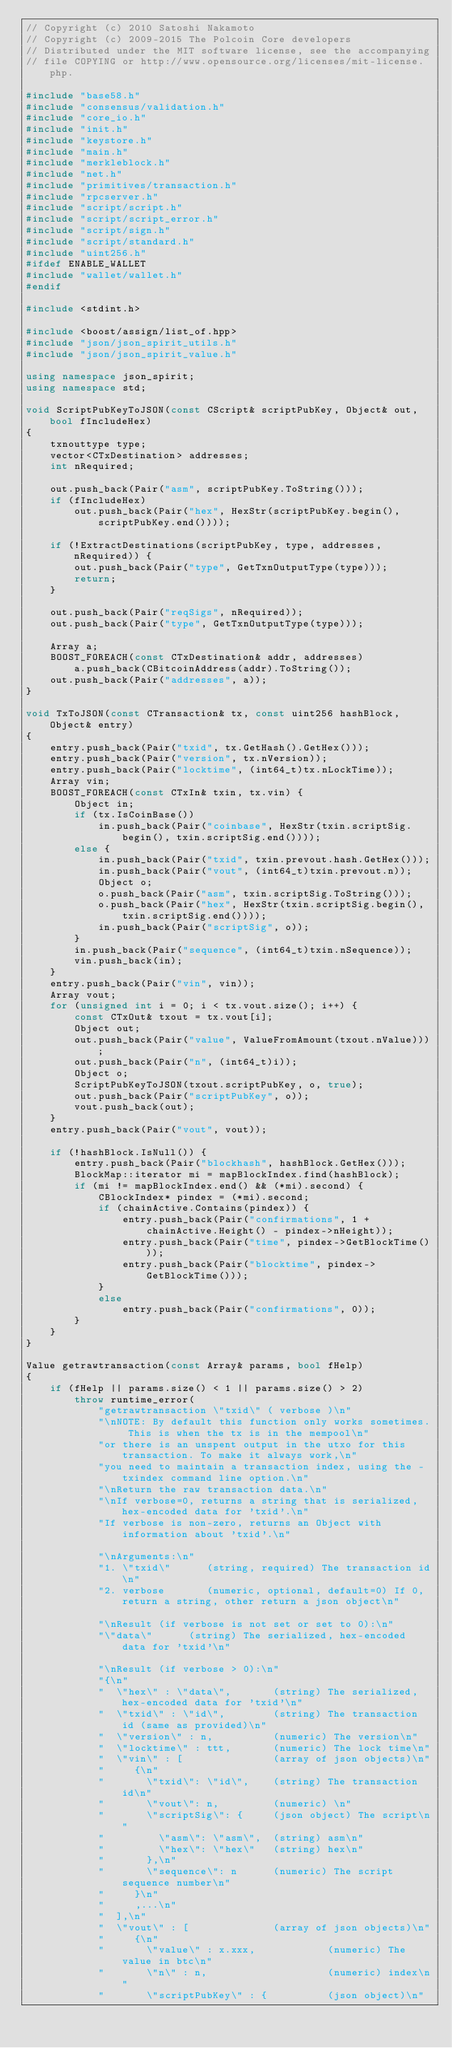Convert code to text. <code><loc_0><loc_0><loc_500><loc_500><_C++_>// Copyright (c) 2010 Satoshi Nakamoto
// Copyright (c) 2009-2015 The Polcoin Core developers
// Distributed under the MIT software license, see the accompanying
// file COPYING or http://www.opensource.org/licenses/mit-license.php.

#include "base58.h"
#include "consensus/validation.h"
#include "core_io.h"
#include "init.h"
#include "keystore.h"
#include "main.h"
#include "merkleblock.h"
#include "net.h"
#include "primitives/transaction.h"
#include "rpcserver.h"
#include "script/script.h"
#include "script/script_error.h"
#include "script/sign.h"
#include "script/standard.h"
#include "uint256.h"
#ifdef ENABLE_WALLET
#include "wallet/wallet.h"
#endif

#include <stdint.h>

#include <boost/assign/list_of.hpp>
#include "json/json_spirit_utils.h"
#include "json/json_spirit_value.h"

using namespace json_spirit;
using namespace std;

void ScriptPubKeyToJSON(const CScript& scriptPubKey, Object& out, bool fIncludeHex)
{
    txnouttype type;
    vector<CTxDestination> addresses;
    int nRequired;

    out.push_back(Pair("asm", scriptPubKey.ToString()));
    if (fIncludeHex)
        out.push_back(Pair("hex", HexStr(scriptPubKey.begin(), scriptPubKey.end())));

    if (!ExtractDestinations(scriptPubKey, type, addresses, nRequired)) {
        out.push_back(Pair("type", GetTxnOutputType(type)));
        return;
    }

    out.push_back(Pair("reqSigs", nRequired));
    out.push_back(Pair("type", GetTxnOutputType(type)));

    Array a;
    BOOST_FOREACH(const CTxDestination& addr, addresses)
        a.push_back(CBitcoinAddress(addr).ToString());
    out.push_back(Pair("addresses", a));
}

void TxToJSON(const CTransaction& tx, const uint256 hashBlock, Object& entry)
{
    entry.push_back(Pair("txid", tx.GetHash().GetHex()));
    entry.push_back(Pair("version", tx.nVersion));
    entry.push_back(Pair("locktime", (int64_t)tx.nLockTime));
    Array vin;
    BOOST_FOREACH(const CTxIn& txin, tx.vin) {
        Object in;
        if (tx.IsCoinBase())
            in.push_back(Pair("coinbase", HexStr(txin.scriptSig.begin(), txin.scriptSig.end())));
        else {
            in.push_back(Pair("txid", txin.prevout.hash.GetHex()));
            in.push_back(Pair("vout", (int64_t)txin.prevout.n));
            Object o;
            o.push_back(Pair("asm", txin.scriptSig.ToString()));
            o.push_back(Pair("hex", HexStr(txin.scriptSig.begin(), txin.scriptSig.end())));
            in.push_back(Pair("scriptSig", o));
        }
        in.push_back(Pair("sequence", (int64_t)txin.nSequence));
        vin.push_back(in);
    }
    entry.push_back(Pair("vin", vin));
    Array vout;
    for (unsigned int i = 0; i < tx.vout.size(); i++) {
        const CTxOut& txout = tx.vout[i];
        Object out;
        out.push_back(Pair("value", ValueFromAmount(txout.nValue)));
        out.push_back(Pair("n", (int64_t)i));
        Object o;
        ScriptPubKeyToJSON(txout.scriptPubKey, o, true);
        out.push_back(Pair("scriptPubKey", o));
        vout.push_back(out);
    }
    entry.push_back(Pair("vout", vout));

    if (!hashBlock.IsNull()) {
        entry.push_back(Pair("blockhash", hashBlock.GetHex()));
        BlockMap::iterator mi = mapBlockIndex.find(hashBlock);
        if (mi != mapBlockIndex.end() && (*mi).second) {
            CBlockIndex* pindex = (*mi).second;
            if (chainActive.Contains(pindex)) {
                entry.push_back(Pair("confirmations", 1 + chainActive.Height() - pindex->nHeight));
                entry.push_back(Pair("time", pindex->GetBlockTime()));
                entry.push_back(Pair("blocktime", pindex->GetBlockTime()));
            }
            else
                entry.push_back(Pair("confirmations", 0));
        }
    }
}

Value getrawtransaction(const Array& params, bool fHelp)
{
    if (fHelp || params.size() < 1 || params.size() > 2)
        throw runtime_error(
            "getrawtransaction \"txid\" ( verbose )\n"
            "\nNOTE: By default this function only works sometimes. This is when the tx is in the mempool\n"
            "or there is an unspent output in the utxo for this transaction. To make it always work,\n"
            "you need to maintain a transaction index, using the -txindex command line option.\n"
            "\nReturn the raw transaction data.\n"
            "\nIf verbose=0, returns a string that is serialized, hex-encoded data for 'txid'.\n"
            "If verbose is non-zero, returns an Object with information about 'txid'.\n"

            "\nArguments:\n"
            "1. \"txid\"      (string, required) The transaction id\n"
            "2. verbose       (numeric, optional, default=0) If 0, return a string, other return a json object\n"

            "\nResult (if verbose is not set or set to 0):\n"
            "\"data\"      (string) The serialized, hex-encoded data for 'txid'\n"

            "\nResult (if verbose > 0):\n"
            "{\n"
            "  \"hex\" : \"data\",       (string) The serialized, hex-encoded data for 'txid'\n"
            "  \"txid\" : \"id\",        (string) The transaction id (same as provided)\n"
            "  \"version\" : n,          (numeric) The version\n"
            "  \"locktime\" : ttt,       (numeric) The lock time\n"
            "  \"vin\" : [               (array of json objects)\n"
            "     {\n"
            "       \"txid\": \"id\",    (string) The transaction id\n"
            "       \"vout\": n,         (numeric) \n"
            "       \"scriptSig\": {     (json object) The script\n"
            "         \"asm\": \"asm\",  (string) asm\n"
            "         \"hex\": \"hex\"   (string) hex\n"
            "       },\n"
            "       \"sequence\": n      (numeric) The script sequence number\n"
            "     }\n"
            "     ,...\n"
            "  ],\n"
            "  \"vout\" : [              (array of json objects)\n"
            "     {\n"
            "       \"value\" : x.xxx,            (numeric) The value in btc\n"
            "       \"n\" : n,                    (numeric) index\n"
            "       \"scriptPubKey\" : {          (json object)\n"</code> 